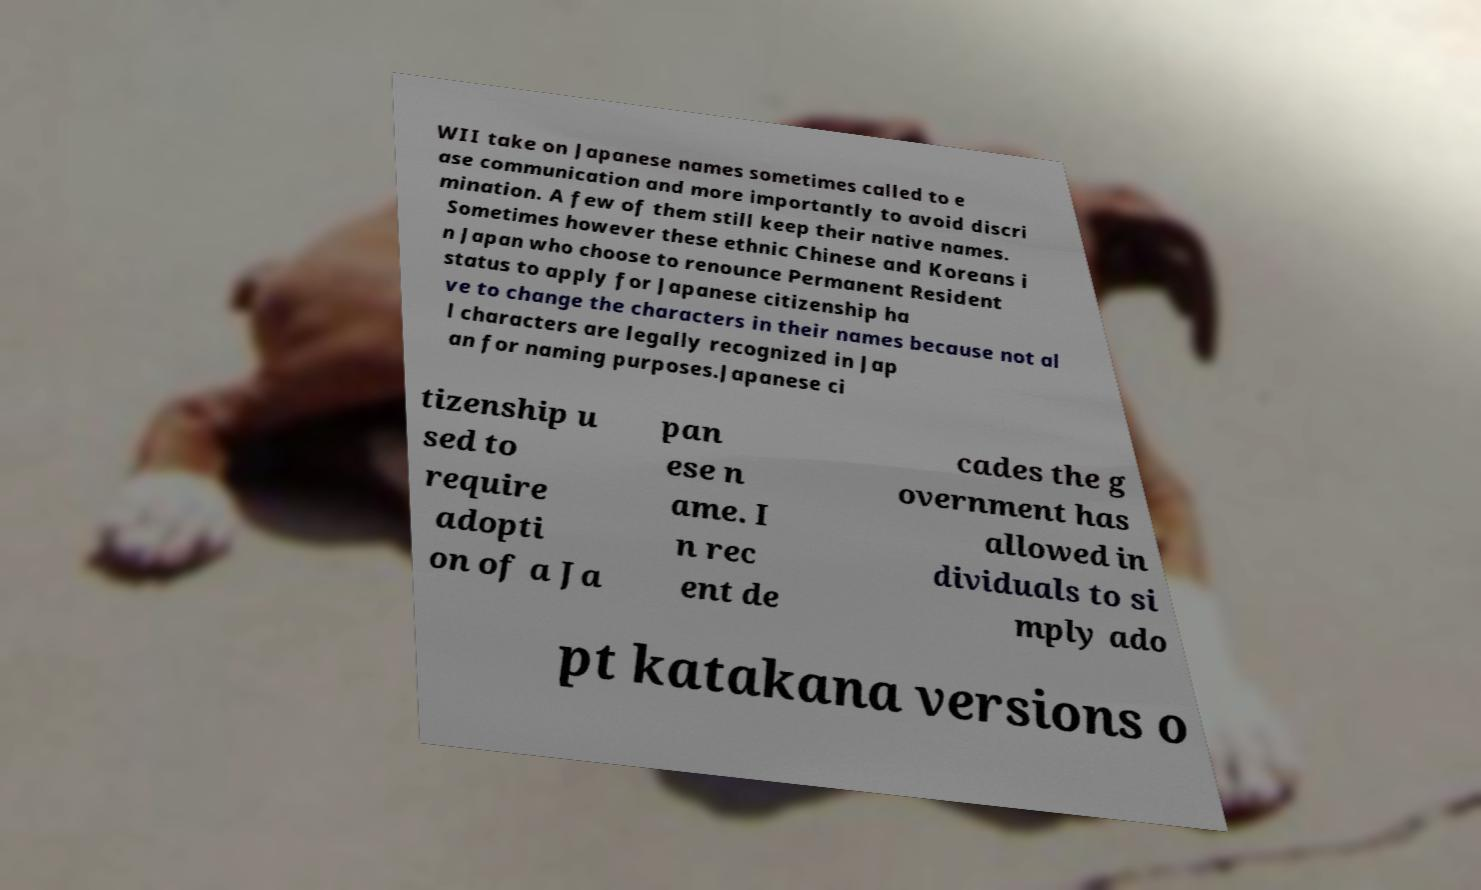Please read and relay the text visible in this image. What does it say? WII take on Japanese names sometimes called to e ase communication and more importantly to avoid discri mination. A few of them still keep their native names. Sometimes however these ethnic Chinese and Koreans i n Japan who choose to renounce Permanent Resident status to apply for Japanese citizenship ha ve to change the characters in their names because not al l characters are legally recognized in Jap an for naming purposes.Japanese ci tizenship u sed to require adopti on of a Ja pan ese n ame. I n rec ent de cades the g overnment has allowed in dividuals to si mply ado pt katakana versions o 